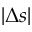<formula> <loc_0><loc_0><loc_500><loc_500>| \Delta s |</formula> 